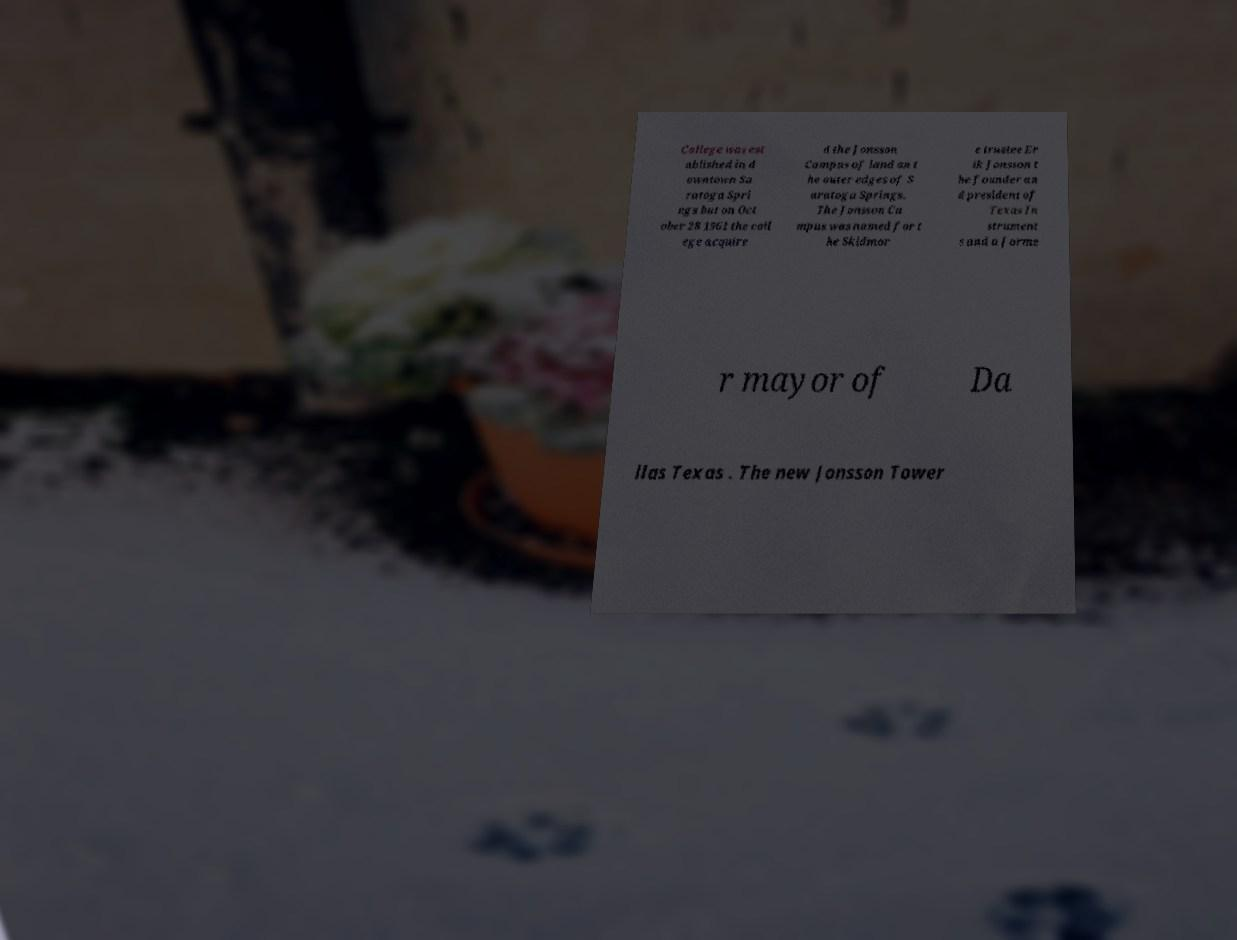There's text embedded in this image that I need extracted. Can you transcribe it verbatim? College was est ablished in d owntown Sa ratoga Spri ngs but on Oct ober 28 1961 the coll ege acquire d the Jonsson Campus of land on t he outer edges of S aratoga Springs. The Jonsson Ca mpus was named for t he Skidmor e trustee Er ik Jonsson t he founder an d president of Texas In strument s and a forme r mayor of Da llas Texas . The new Jonsson Tower 